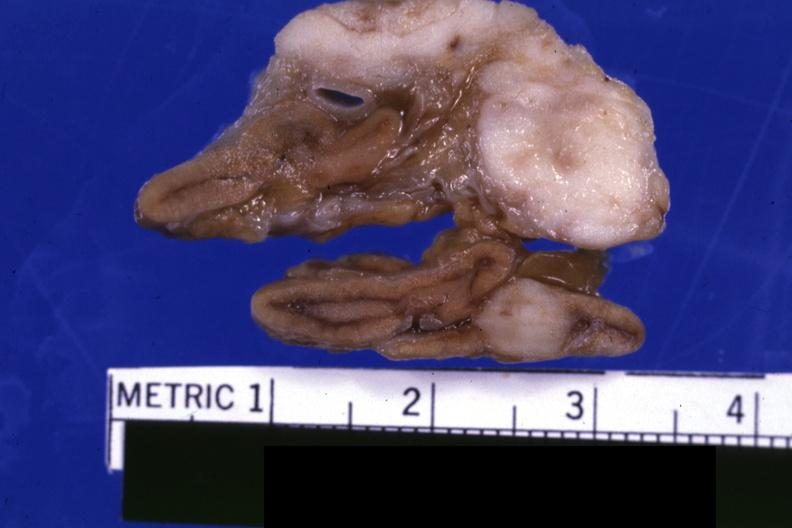does this section showing liver with tumor mass in hilar area tumor show fixed tissue close-up excellent except for color?
Answer the question using a single word or phrase. No 